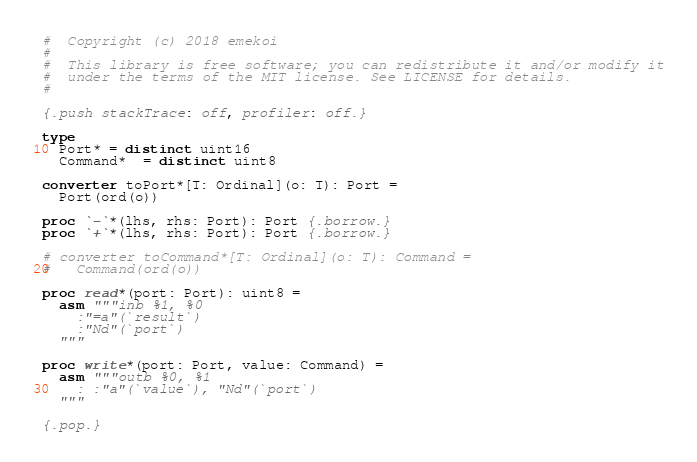Convert code to text. <code><loc_0><loc_0><loc_500><loc_500><_Nim_>#  Copyright (c) 2018 emekoi
#
#  This library is free software; you can redistribute it and/or modify it
#  under the terms of the MIT license. See LICENSE for details.
#

{.push stackTrace: off, profiler: off.}

type
  Port* = distinct uint16
  Command*  = distinct uint8

converter toPort*[T: Ordinal](o: T): Port =
  Port(ord(o))

proc `-`*(lhs, rhs: Port): Port {.borrow.}
proc `+`*(lhs, rhs: Port): Port {.borrow.}

# converter toCommand*[T: Ordinal](o: T): Command =
#   Command(ord(o))

proc read*(port: Port): uint8 =
  asm """inb %1, %0
    :"=a"(`result`)
    :"Nd"(`port`)
  """

proc write*(port: Port, value: Command) =
  asm """outb %0, %1
    : :"a"(`value`), "Nd"(`port`)
  """

{.pop.}
</code> 